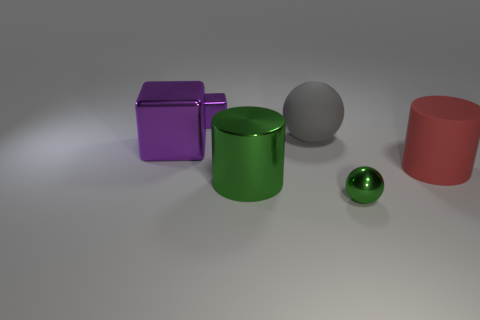How does the light interact with the surfaces of the objects? The light creates a soft reflection on the objects with shiny surfaces, such as the green cylinder and the purple cube, enhancing their glossiness. On the matte surfaces, like the gray sphere and the tan backdrop, the light diffuses more, giving a softer appearance. 